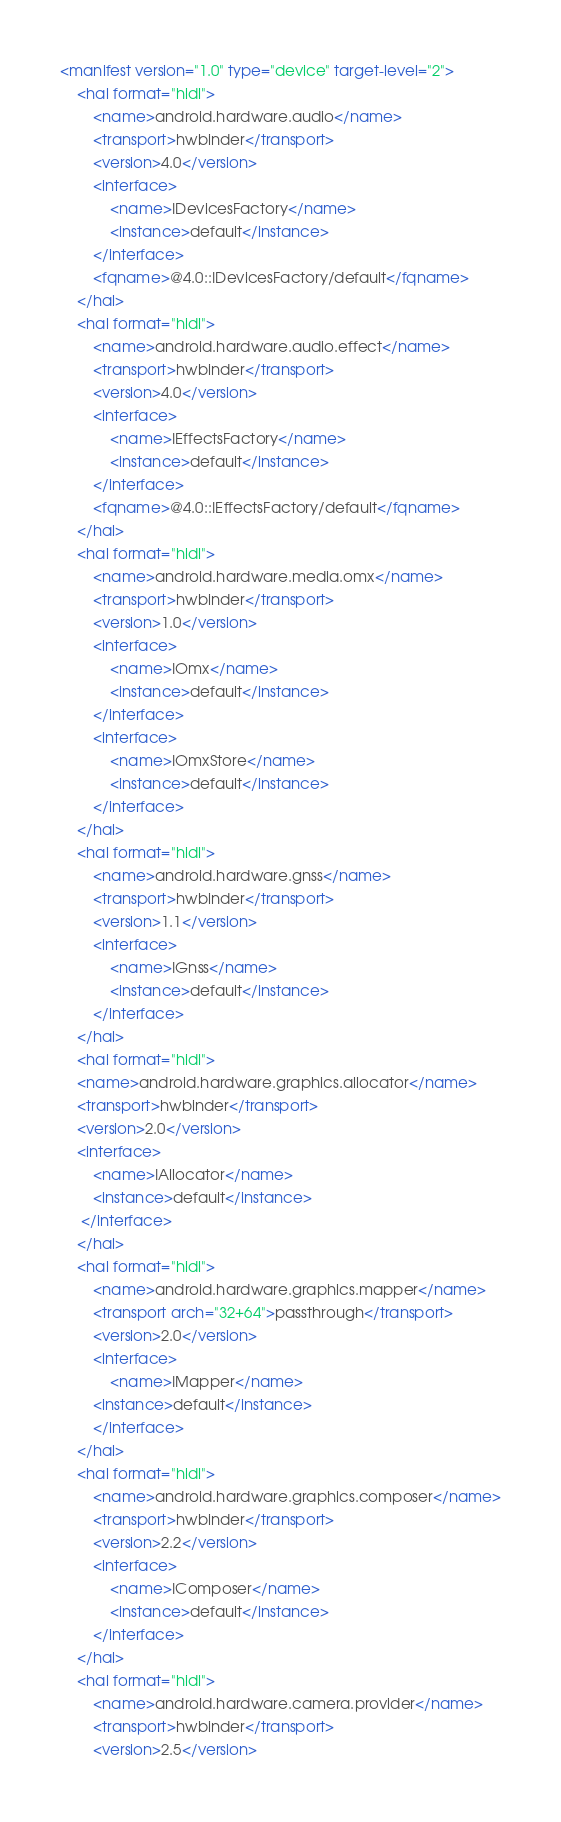Convert code to text. <code><loc_0><loc_0><loc_500><loc_500><_XML_><manifest version="1.0" type="device" target-level="2">
    <hal format="hidl">
        <name>android.hardware.audio</name>
        <transport>hwbinder</transport>
        <version>4.0</version>
        <interface>
            <name>IDevicesFactory</name>
            <instance>default</instance>
        </interface>
        <fqname>@4.0::IDevicesFactory/default</fqname>
    </hal>
    <hal format="hidl">
        <name>android.hardware.audio.effect</name>
        <transport>hwbinder</transport>
        <version>4.0</version>
        <interface>
            <name>IEffectsFactory</name>
            <instance>default</instance>
        </interface>
        <fqname>@4.0::IEffectsFactory/default</fqname>
    </hal>
    <hal format="hidl">
        <name>android.hardware.media.omx</name>
        <transport>hwbinder</transport>
        <version>1.0</version>
        <interface>
            <name>IOmx</name>
            <instance>default</instance>
        </interface>
        <interface>
            <name>IOmxStore</name>
            <instance>default</instance>
        </interface>
    </hal>
    <hal format="hidl">
        <name>android.hardware.gnss</name>
        <transport>hwbinder</transport>
        <version>1.1</version>
        <interface>
            <name>IGnss</name>
            <instance>default</instance>
        </interface>
    </hal>
    <hal format="hidl">
	<name>android.hardware.graphics.allocator</name>
	<transport>hwbinder</transport>
	<version>2.0</version>
	<interface>
	    <name>IAllocator</name>
	    <instance>default</instance>
	 </interface>
	</hal>
    <hal format="hidl">
        <name>android.hardware.graphics.mapper</name>
        <transport arch="32+64">passthrough</transport>
        <version>2.0</version>
        <interface>
            <name>IMapper</name>
	    <instance>default</instance>
        </interface>
    </hal>
    <hal format="hidl">
        <name>android.hardware.graphics.composer</name>
        <transport>hwbinder</transport>
        <version>2.2</version>
        <interface>
            <name>IComposer</name>
            <instance>default</instance>
        </interface>
    </hal>
    <hal format="hidl">
        <name>android.hardware.camera.provider</name>
        <transport>hwbinder</transport>
        <version>2.5</version></code> 